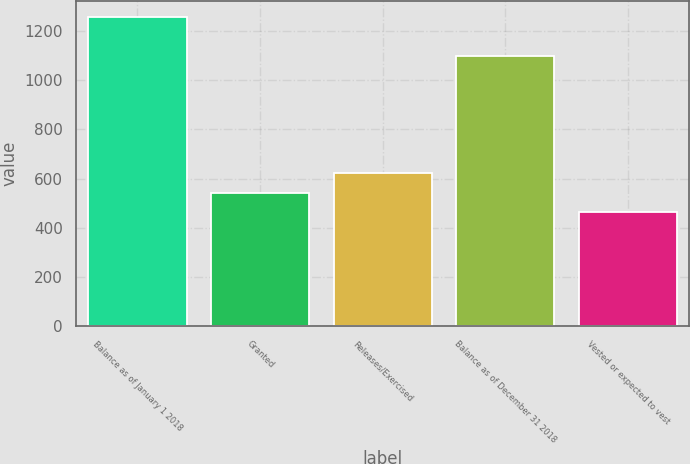Convert chart. <chart><loc_0><loc_0><loc_500><loc_500><bar_chart><fcel>Balance as of January 1 2018<fcel>Granted<fcel>Releases/Exercised<fcel>Balance as of December 31 2018<fcel>Vested or expected to vest<nl><fcel>1257<fcel>541.5<fcel>621<fcel>1097<fcel>462<nl></chart> 